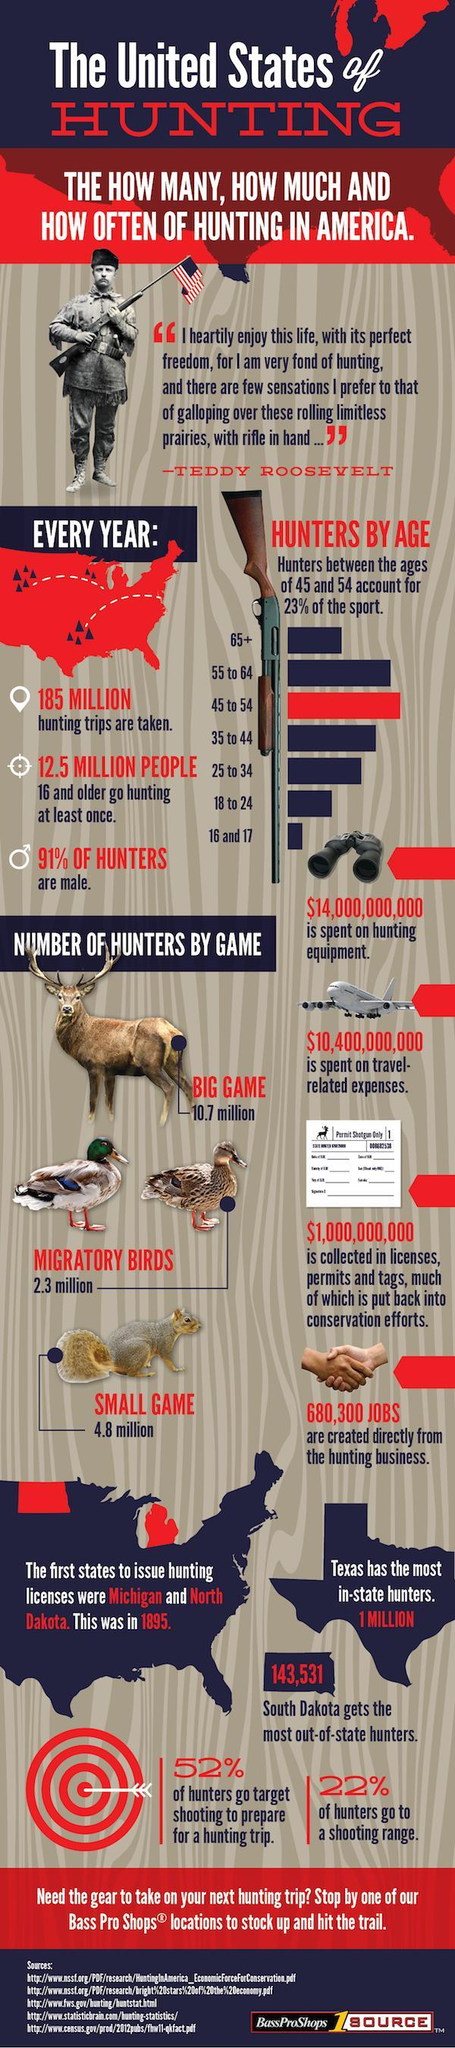Which age group accounts for the second highest group of hunters ?
Answer the question with a short phrase. 55 to 64 